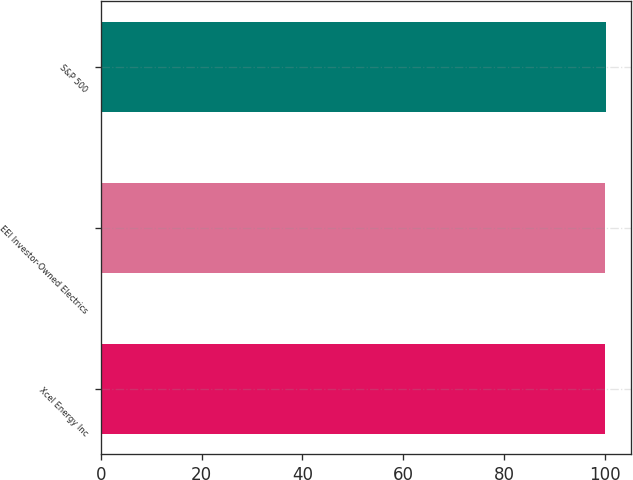<chart> <loc_0><loc_0><loc_500><loc_500><bar_chart><fcel>Xcel Energy Inc<fcel>EEI Investor-Owned Electrics<fcel>S&P 500<nl><fcel>100<fcel>100.1<fcel>100.2<nl></chart> 